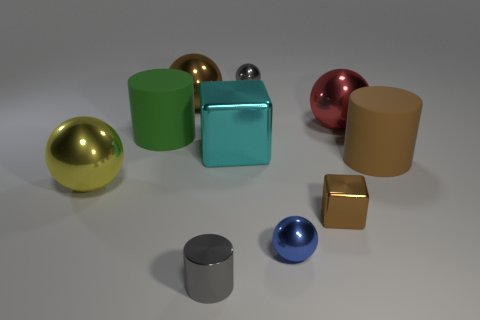Can you describe the lighting and shadows in the image? The lighting in the image is coming from above, as indicated by the shadows directly beneath the objects. The light source seems diffused, leading to soft-edged shadows that are not very dark, suggesting a natural or ambient light environment rather than a direct spotlight. 